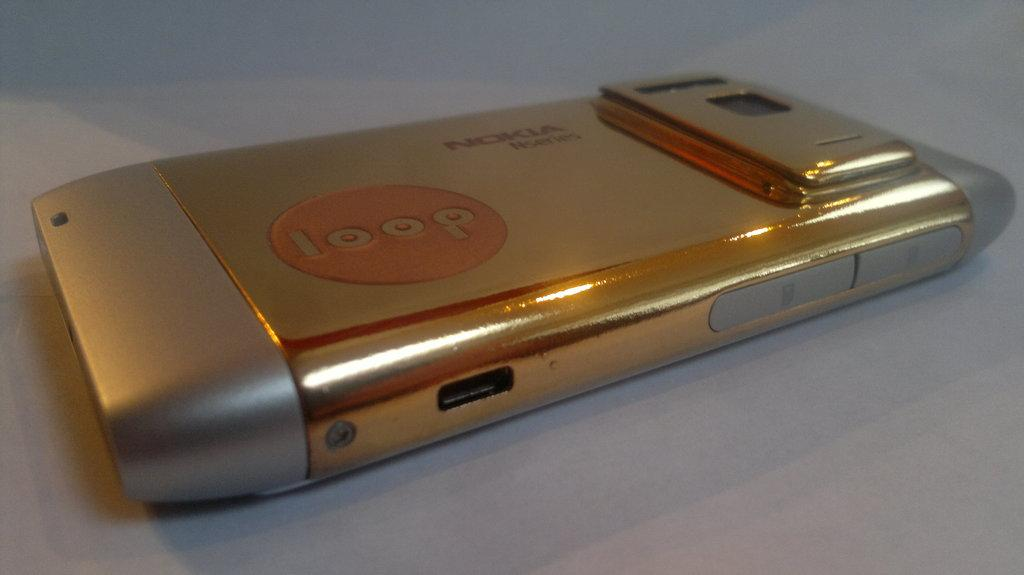<image>
Offer a succinct explanation of the picture presented. a gold nokia phone that says 'loop' on the back of it 